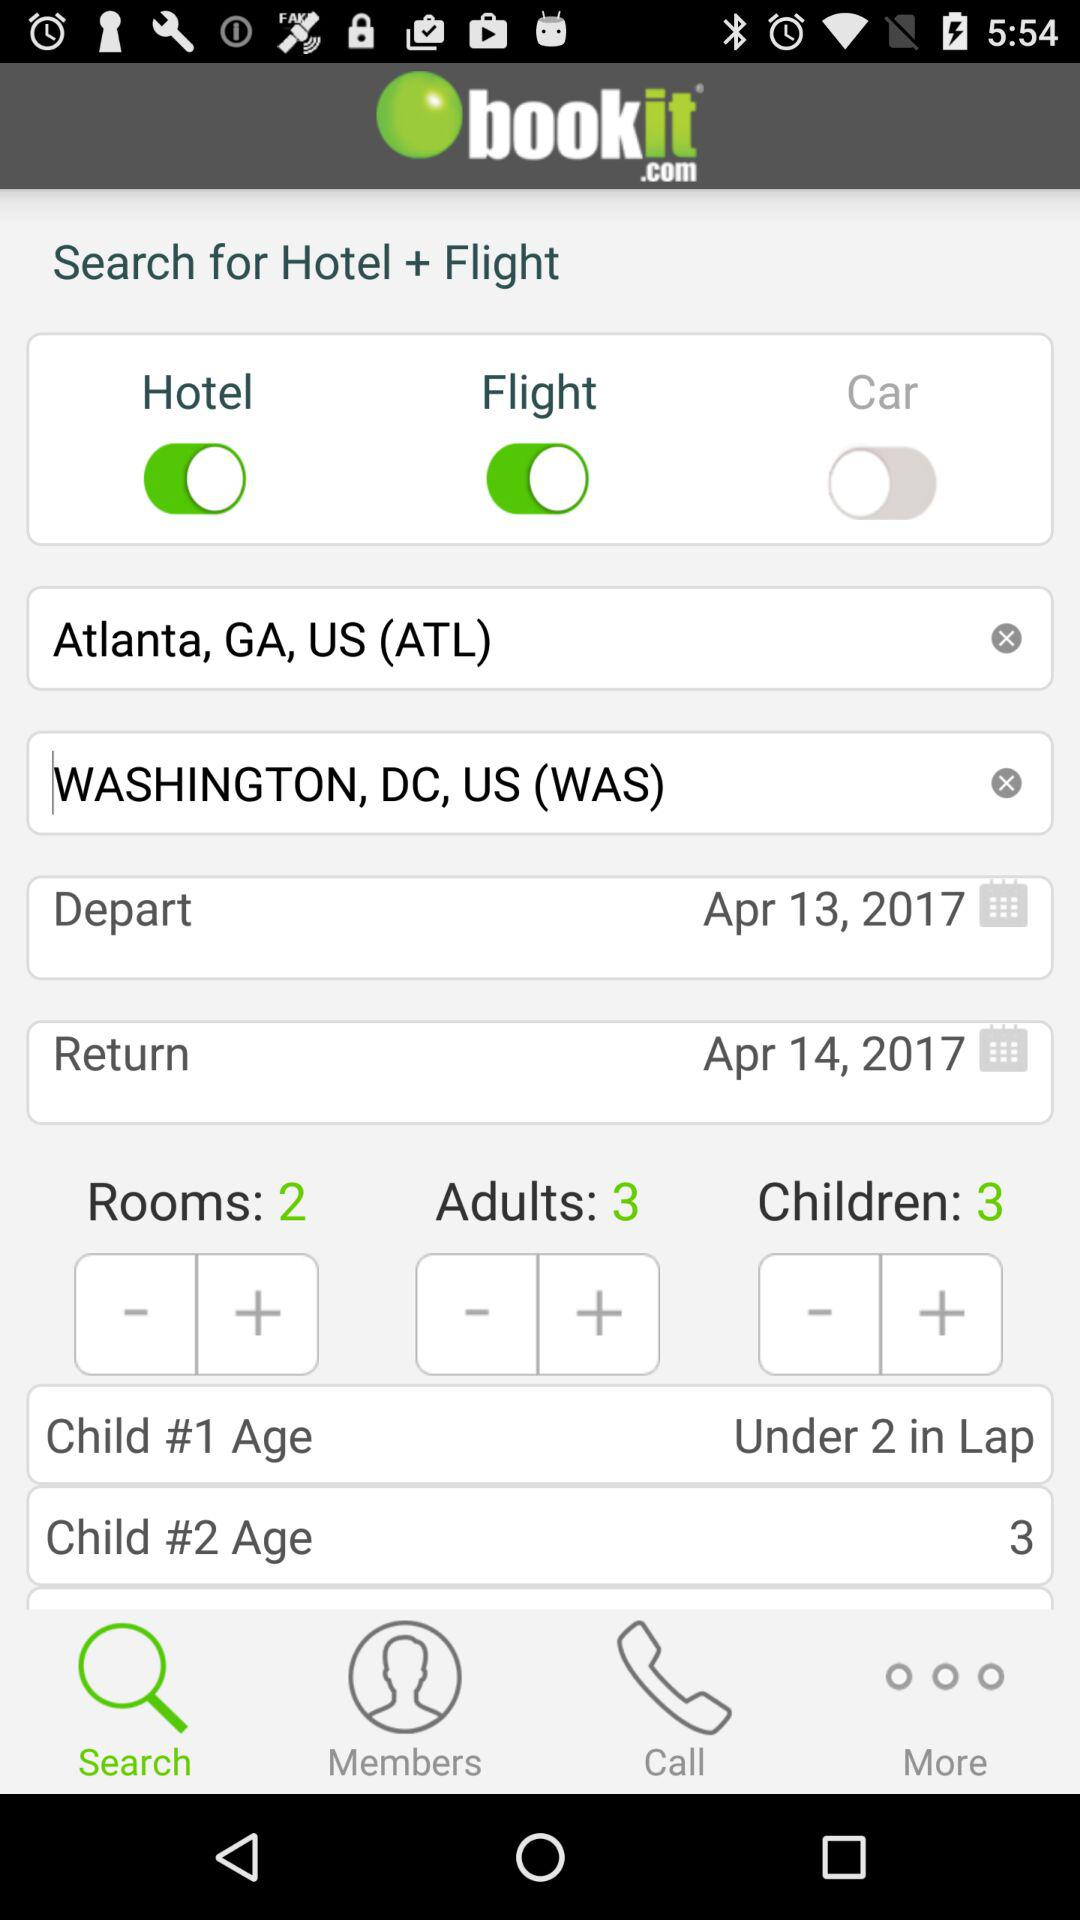How many days are there between the departure and return dates?
Answer the question using a single word or phrase. 1 